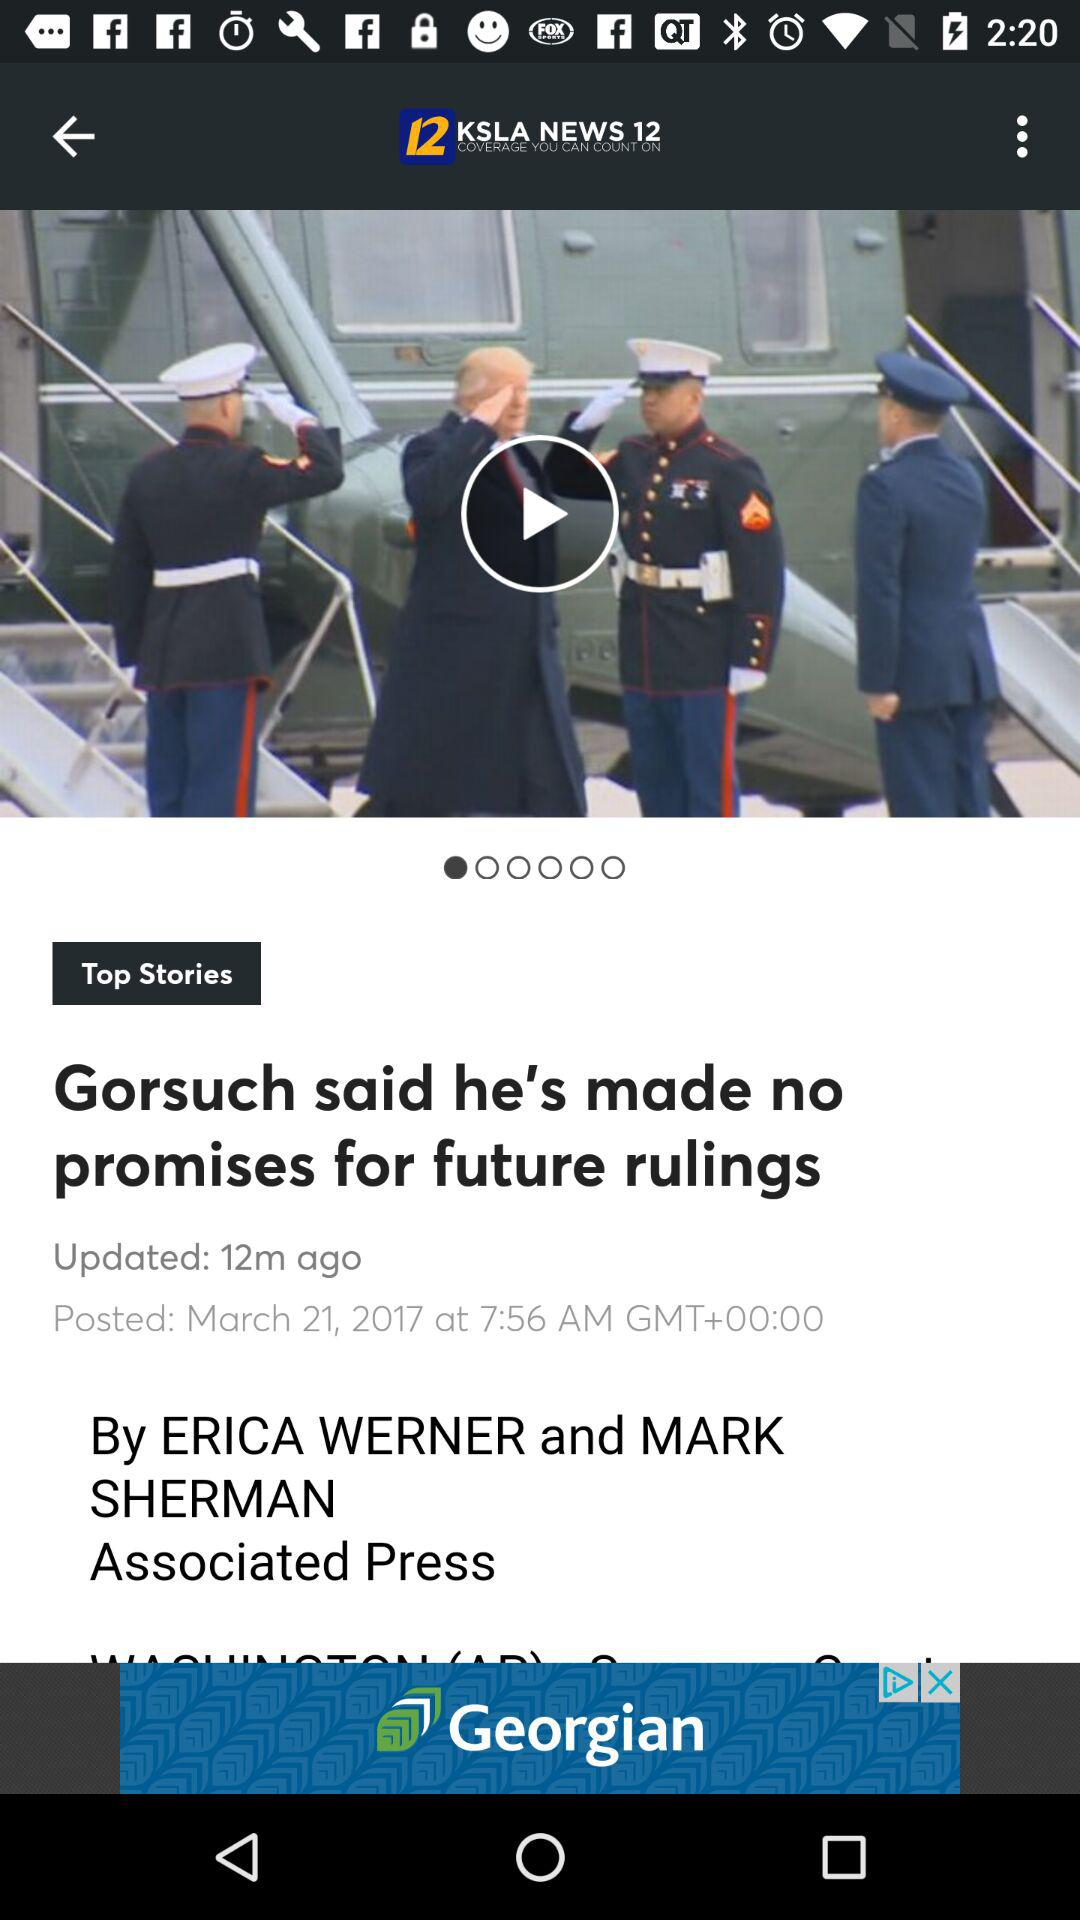What is the name of the application? The name of the application is "KSLA NEWS 12". 